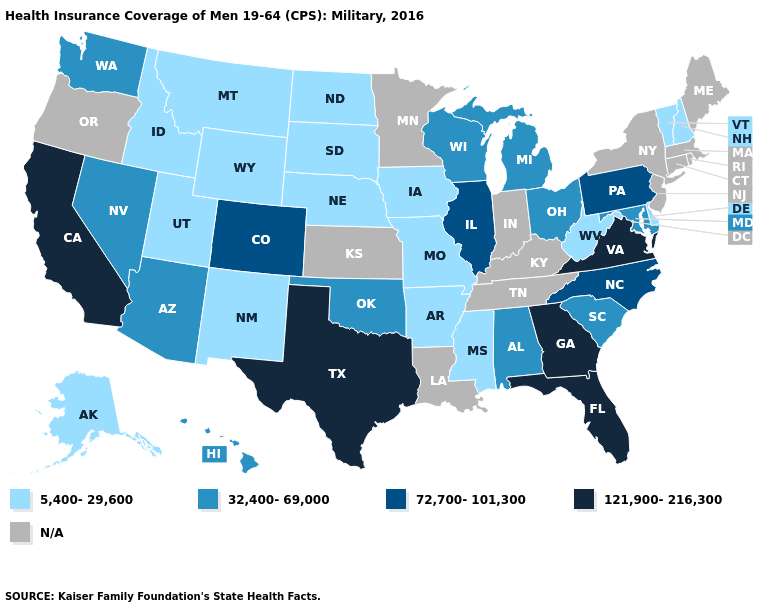Is the legend a continuous bar?
Be succinct. No. Among the states that border Utah , does Wyoming have the lowest value?
Keep it brief. Yes. Does the first symbol in the legend represent the smallest category?
Concise answer only. Yes. What is the value of Illinois?
Keep it brief. 72,700-101,300. Which states have the lowest value in the Northeast?
Write a very short answer. New Hampshire, Vermont. Which states have the lowest value in the Northeast?
Short answer required. New Hampshire, Vermont. Name the states that have a value in the range 5,400-29,600?
Give a very brief answer. Alaska, Arkansas, Delaware, Idaho, Iowa, Mississippi, Missouri, Montana, Nebraska, New Hampshire, New Mexico, North Dakota, South Dakota, Utah, Vermont, West Virginia, Wyoming. What is the lowest value in the MidWest?
Quick response, please. 5,400-29,600. Does Pennsylvania have the lowest value in the Northeast?
Concise answer only. No. Name the states that have a value in the range 121,900-216,300?
Be succinct. California, Florida, Georgia, Texas, Virginia. What is the value of Idaho?
Answer briefly. 5,400-29,600. What is the lowest value in the South?
Concise answer only. 5,400-29,600. Name the states that have a value in the range 72,700-101,300?
Keep it brief. Colorado, Illinois, North Carolina, Pennsylvania. Among the states that border South Carolina , which have the lowest value?
Write a very short answer. North Carolina. 